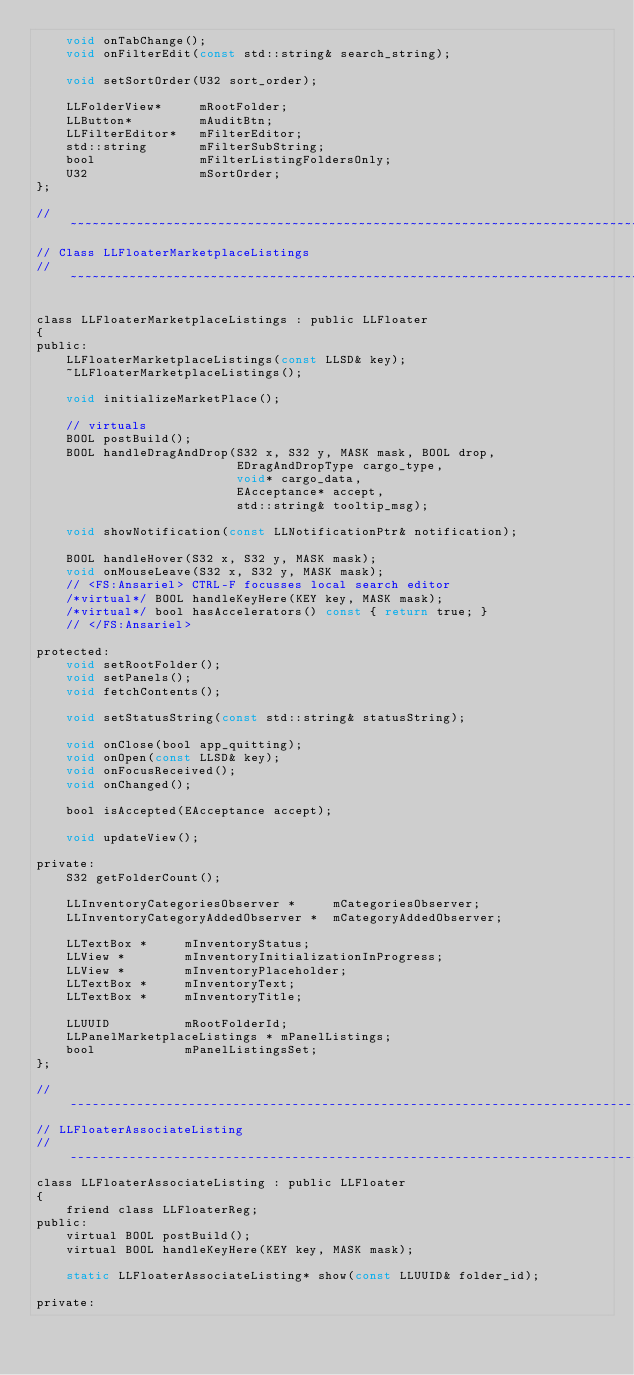<code> <loc_0><loc_0><loc_500><loc_500><_C_>    void onTabChange();
    void onFilterEdit(const std::string& search_string);
    
    void setSortOrder(U32 sort_order);
    
    LLFolderView*     mRootFolder;
    LLButton*         mAuditBtn;
	LLFilterEditor*	  mFilterEditor;
	std::string		  mFilterSubString;
    bool              mFilterListingFoldersOnly;
    U32               mSortOrder;
};

//~~~~~~~~~~~~~~~~~~~~~~~~~~~~~~~~~~~~~~~~~~~~~~~~~~~~~~~~~~~~~~~~~~~~~~~~~~~~~
// Class LLFloaterMarketplaceListings
//~~~~~~~~~~~~~~~~~~~~~~~~~~~~~~~~~~~~~~~~~~~~~~~~~~~~~~~~~~~~~~~~~~~~~~~~~~~~~

class LLFloaterMarketplaceListings : public LLFloater
{
public:
	LLFloaterMarketplaceListings(const LLSD& key);
	~LLFloaterMarketplaceListings();
	
	void initializeMarketPlace();
    
	// virtuals
	BOOL postBuild();
	BOOL handleDragAndDrop(S32 x, S32 y, MASK mask, BOOL drop,
						   EDragAndDropType cargo_type,
						   void* cargo_data,
						   EAcceptance* accept,
						   std::string& tooltip_msg);
	
	void showNotification(const LLNotificationPtr& notification);
    
	BOOL handleHover(S32 x, S32 y, MASK mask);
	void onMouseLeave(S32 x, S32 y, MASK mask);
	// <FS:Ansariel> CTRL-F focusses local search editor
	/*virtual*/ BOOL handleKeyHere(KEY key, MASK mask);
	/*virtual*/ bool hasAccelerators() const { return true; }
	// </FS:Ansariel>
    
protected:
	void setRootFolder();
	void setPanels();
	void fetchContents();
    
	void setStatusString(const std::string& statusString);

	void onClose(bool app_quitting);
	void onOpen(const LLSD& key);
	void onFocusReceived();
	void onChanged();
    
    bool isAccepted(EAcceptance accept);
	
	void updateView();
    
private:
    S32 getFolderCount();

	LLInventoryCategoriesObserver *		mCategoriesObserver;
	LLInventoryCategoryAddedObserver *	mCategoryAddedObserver;
		
	LLTextBox *		mInventoryStatus;
	LLView *		mInventoryInitializationInProgress;
	LLView *		mInventoryPlaceholder;
	LLTextBox *		mInventoryText;
	LLTextBox *		mInventoryTitle;

	LLUUID			mRootFolderId;
	LLPanelMarketplaceListings * mPanelListings;
    bool            mPanelListingsSet;
};

//-----------------------------------------------------------------------------
// LLFloaterAssociateListing
//-----------------------------------------------------------------------------
class LLFloaterAssociateListing : public LLFloater
{
	friend class LLFloaterReg;
public:
	virtual BOOL postBuild();
	virtual BOOL handleKeyHere(KEY key, MASK mask);
    
	static LLFloaterAssociateListing* show(const LLUUID& folder_id);
    
private:</code> 